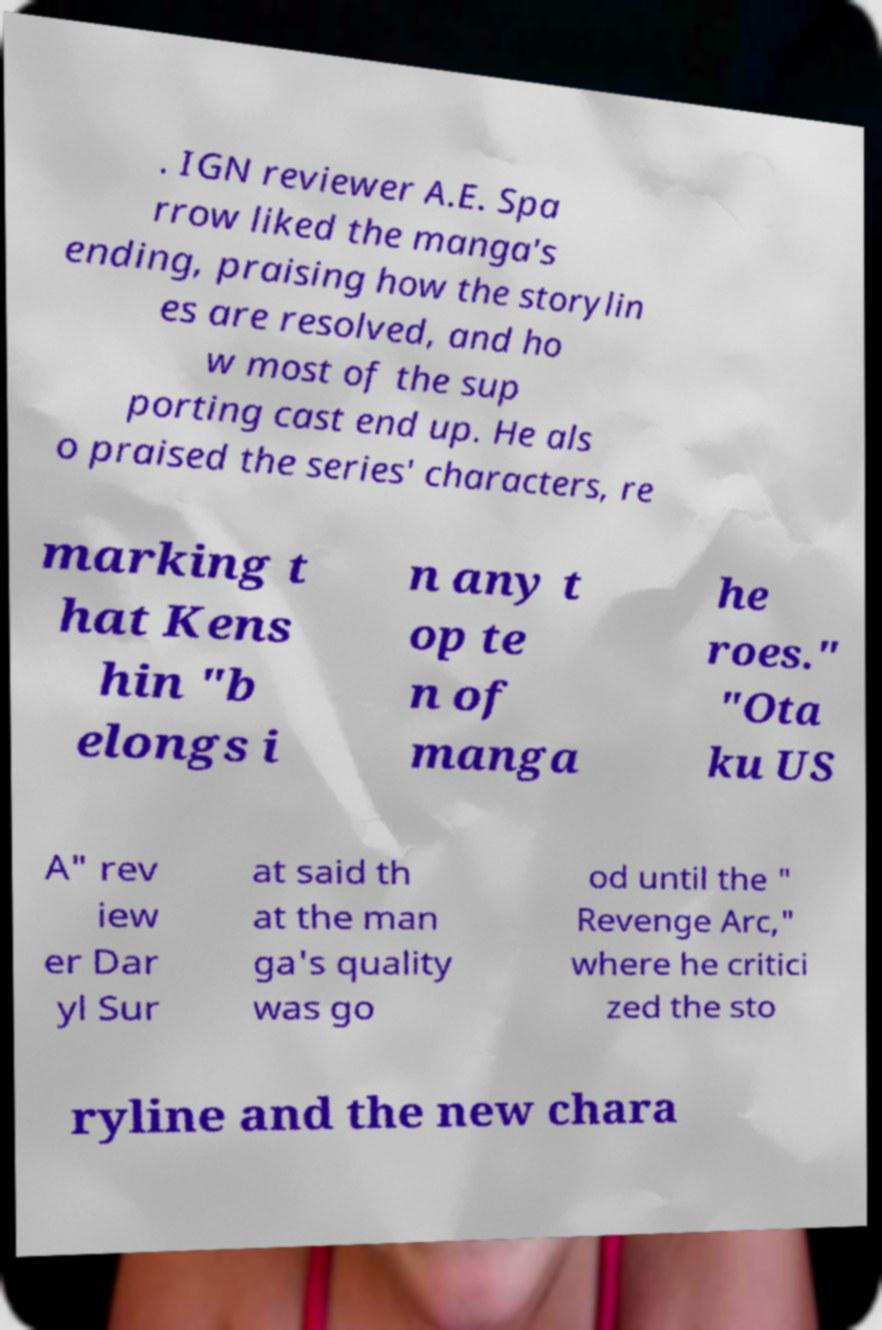Please identify and transcribe the text found in this image. . IGN reviewer A.E. Spa rrow liked the manga's ending, praising how the storylin es are resolved, and ho w most of the sup porting cast end up. He als o praised the series' characters, re marking t hat Kens hin "b elongs i n any t op te n of manga he roes." "Ota ku US A" rev iew er Dar yl Sur at said th at the man ga's quality was go od until the " Revenge Arc," where he critici zed the sto ryline and the new chara 